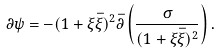<formula> <loc_0><loc_0><loc_500><loc_500>\partial \psi = - ( 1 + \xi \bar { \xi } ) ^ { 2 } \bar { \partial } \left ( \frac { \sigma } { ( 1 + \xi \bar { \xi } ) ^ { 2 } } \right ) .</formula> 